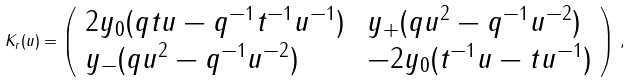<formula> <loc_0><loc_0><loc_500><loc_500>K _ { r } ( u ) = \left ( \begin{array} { l l } 2 y _ { 0 } ( q t u - q ^ { - 1 } t ^ { - 1 } u ^ { - 1 } ) \, & y _ { + } ( q u ^ { 2 } - q ^ { - 1 } u ^ { - 2 } ) \\ y _ { - } ( q u ^ { 2 } - q ^ { - 1 } u ^ { - 2 } ) \, & - 2 y _ { 0 } ( t ^ { - 1 } u - t u ^ { - 1 } ) \end{array} \right ) \, ,</formula> 